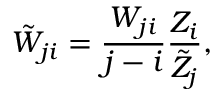<formula> <loc_0><loc_0><loc_500><loc_500>\tilde { W } _ { j i } = \frac { W _ { j i } } { j - i } \frac { Z _ { i } } { \tilde { Z } _ { j } } ,</formula> 